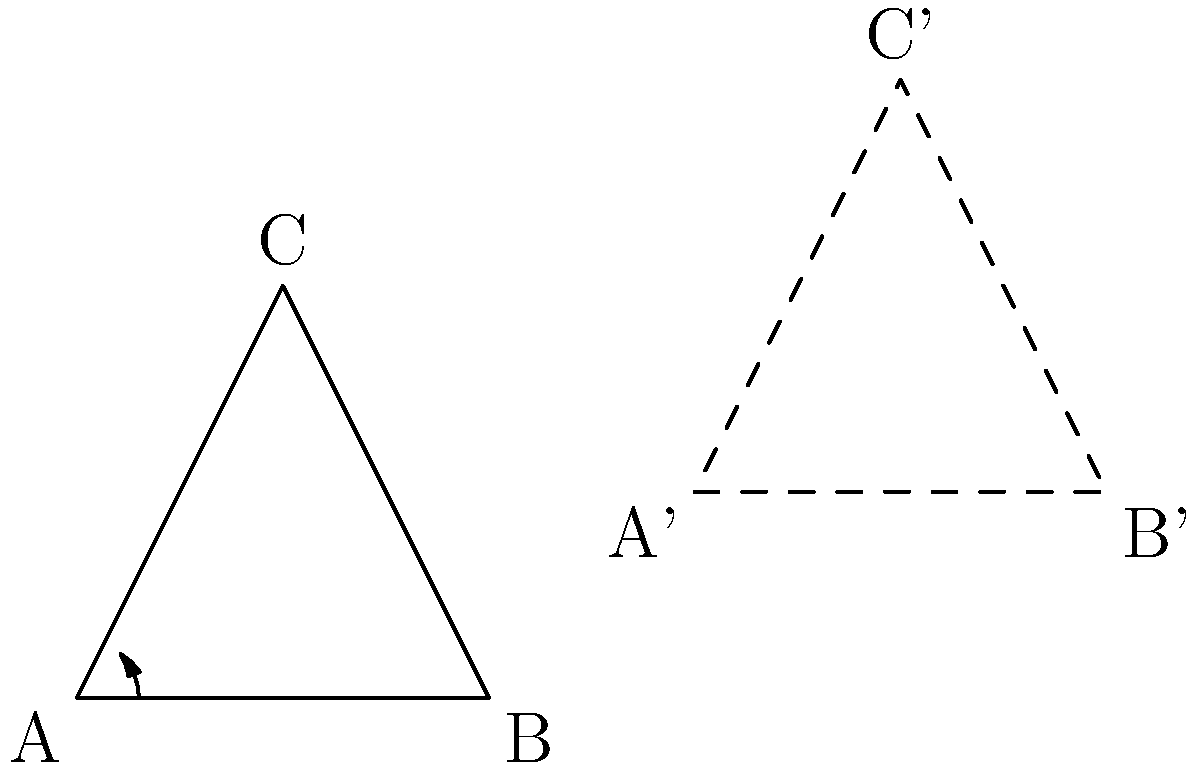In this captcha-like puzzle, triangle ABC has been transformed to triangle A'B'C'. Which sequence of transformations could have been applied to achieve this result? (Hint: Think about the most efficient way to move the triangle without changing its shape or size.) Let's break this down step-by-step:

1. First, observe that triangle ABC and triangle A'B'C' are congruent. This means we're dealing with rigid transformations (isometries) that preserve shape and size.

2. The orientation of the triangle has changed, which suggests a rotation has occurred.

3. The triangle has also moved to a new position, indicating a translation.

4. To determine the specific transformations:
   a) Rotation: The triangle appears to have been rotated 45° counterclockwise around point A.
   b) Translation: After rotation, the triangle was translated 3 units right and 1 unit up.

5. While we could achieve the same result with other combinations of transformations, this sequence (rotation followed by translation) is the most efficient.

Note: This explanation avoids the need for multiple form submissions or captcha repetitions, addressing the persona's disdain for such processes.
Answer: 45° counterclockwise rotation around A, then translation (3,1) 